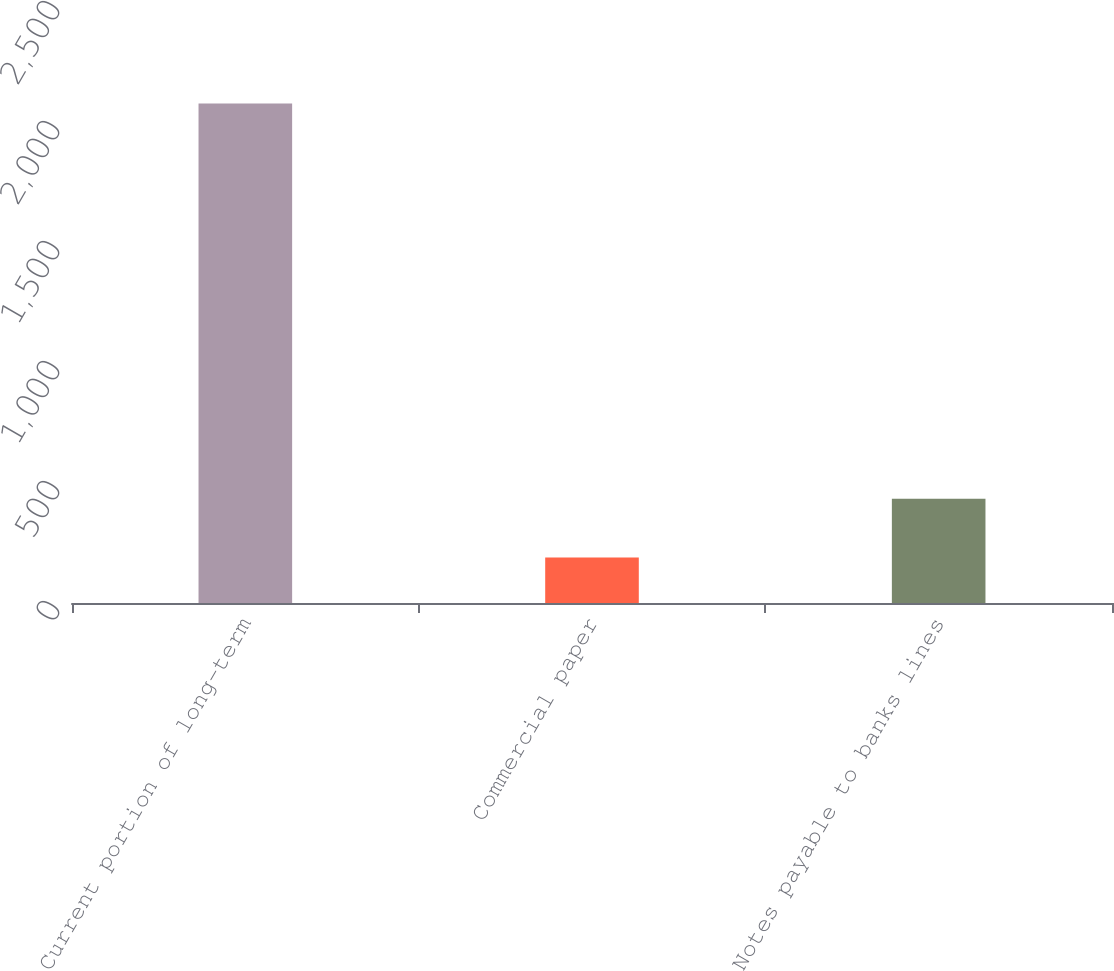<chart> <loc_0><loc_0><loc_500><loc_500><bar_chart><fcel>Current portion of long-term<fcel>Commercial paper<fcel>Notes payable to banks lines<nl><fcel>2081<fcel>190<fcel>434<nl></chart> 